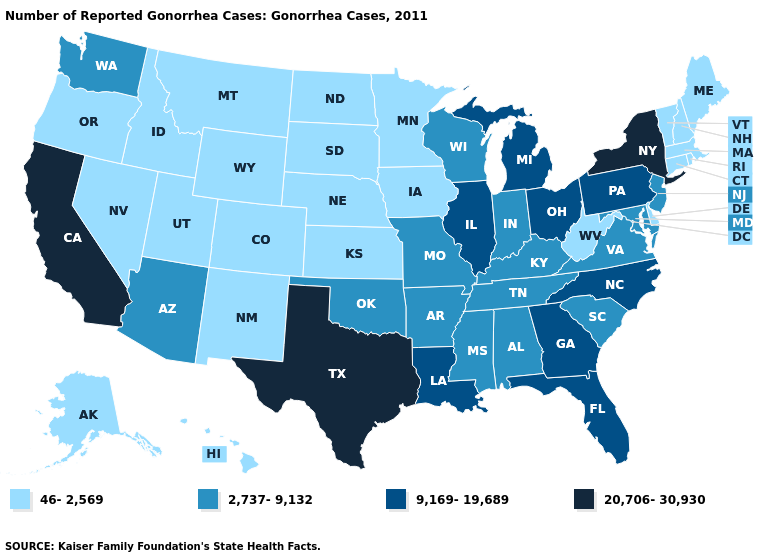Which states have the lowest value in the South?
Give a very brief answer. Delaware, West Virginia. Name the states that have a value in the range 2,737-9,132?
Concise answer only. Alabama, Arizona, Arkansas, Indiana, Kentucky, Maryland, Mississippi, Missouri, New Jersey, Oklahoma, South Carolina, Tennessee, Virginia, Washington, Wisconsin. What is the lowest value in states that border Nebraska?
Short answer required. 46-2,569. What is the value of Connecticut?
Short answer required. 46-2,569. Name the states that have a value in the range 20,706-30,930?
Answer briefly. California, New York, Texas. What is the value of Minnesota?
Answer briefly. 46-2,569. Which states hav the highest value in the Northeast?
Concise answer only. New York. Name the states that have a value in the range 9,169-19,689?
Answer briefly. Florida, Georgia, Illinois, Louisiana, Michigan, North Carolina, Ohio, Pennsylvania. Which states have the highest value in the USA?
Concise answer only. California, New York, Texas. Does Texas have the same value as California?
Give a very brief answer. Yes. Name the states that have a value in the range 2,737-9,132?
Give a very brief answer. Alabama, Arizona, Arkansas, Indiana, Kentucky, Maryland, Mississippi, Missouri, New Jersey, Oklahoma, South Carolina, Tennessee, Virginia, Washington, Wisconsin. Which states have the lowest value in the West?
Be succinct. Alaska, Colorado, Hawaii, Idaho, Montana, Nevada, New Mexico, Oregon, Utah, Wyoming. Does Mississippi have the same value as Arizona?
Answer briefly. Yes. What is the value of Pennsylvania?
Give a very brief answer. 9,169-19,689. What is the lowest value in the West?
Answer briefly. 46-2,569. 